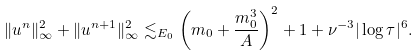<formula> <loc_0><loc_0><loc_500><loc_500>\| u ^ { n } \| _ { \infty } ^ { 2 } + \| u ^ { n + 1 } \| _ { \infty } ^ { 2 } \lesssim _ { E _ { 0 } } \left ( m _ { 0 } + \frac { m _ { 0 } ^ { 3 } } A \right ) ^ { 2 } + 1 + \nu ^ { - 3 } | \log \tau | ^ { 6 } .</formula> 